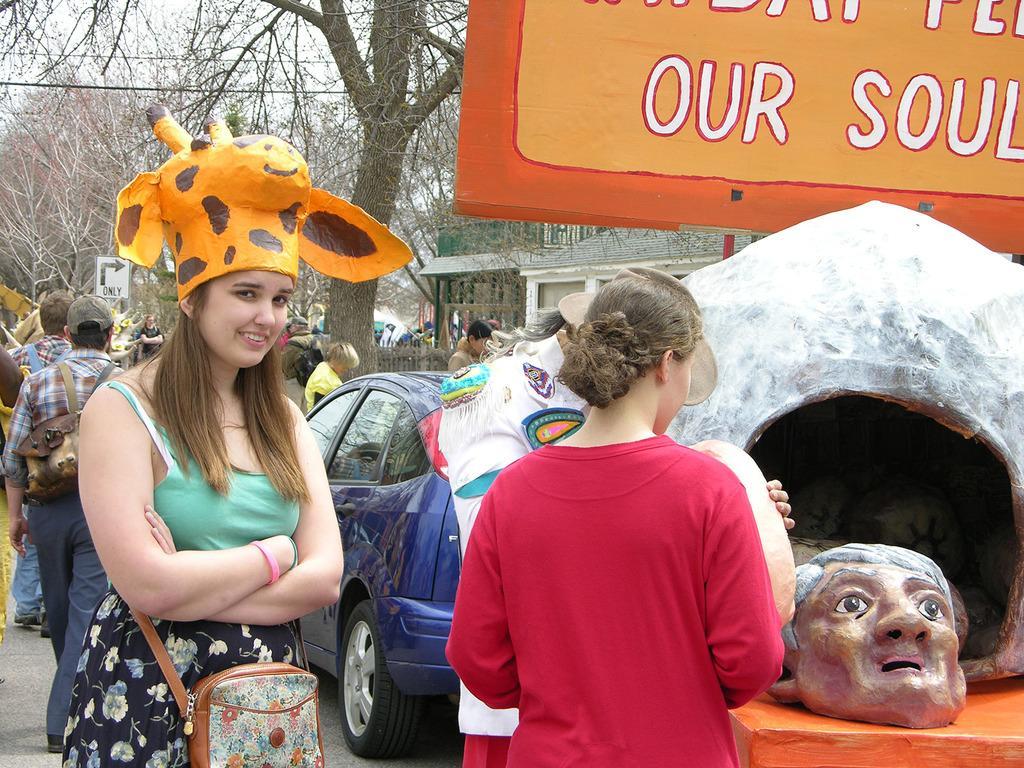In one or two sentences, can you explain what this image depicts? In this image on the road there are many people. Here a girl wearing a cap which is is a shape of animal head. Here there is a project model. This is a board. In the background there are trees, buildings,sign board, fence. Here there is a blue car. 